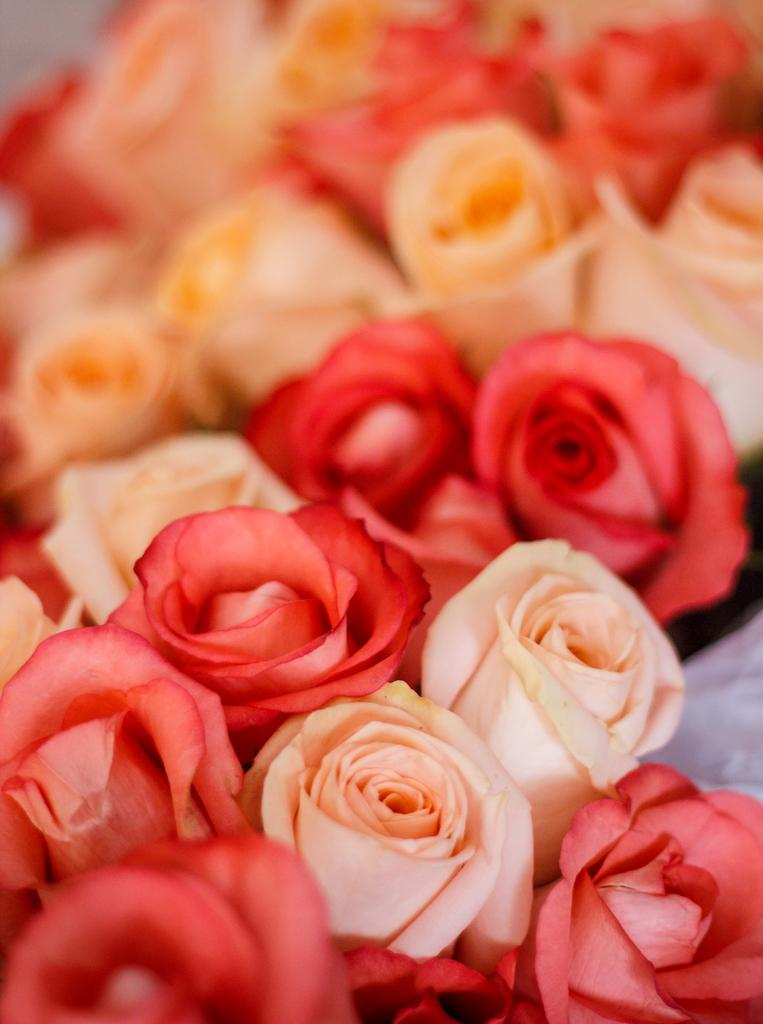What type of living organisms can be seen in the image? Flowers can be seen in the image. What type of war is being depicted in the image? There is no war depicted in the image; it features flowers. Can you hear any songs being sung by the rabbit in the image? There is no rabbit present in the image, and therefore no singing can be heard. 